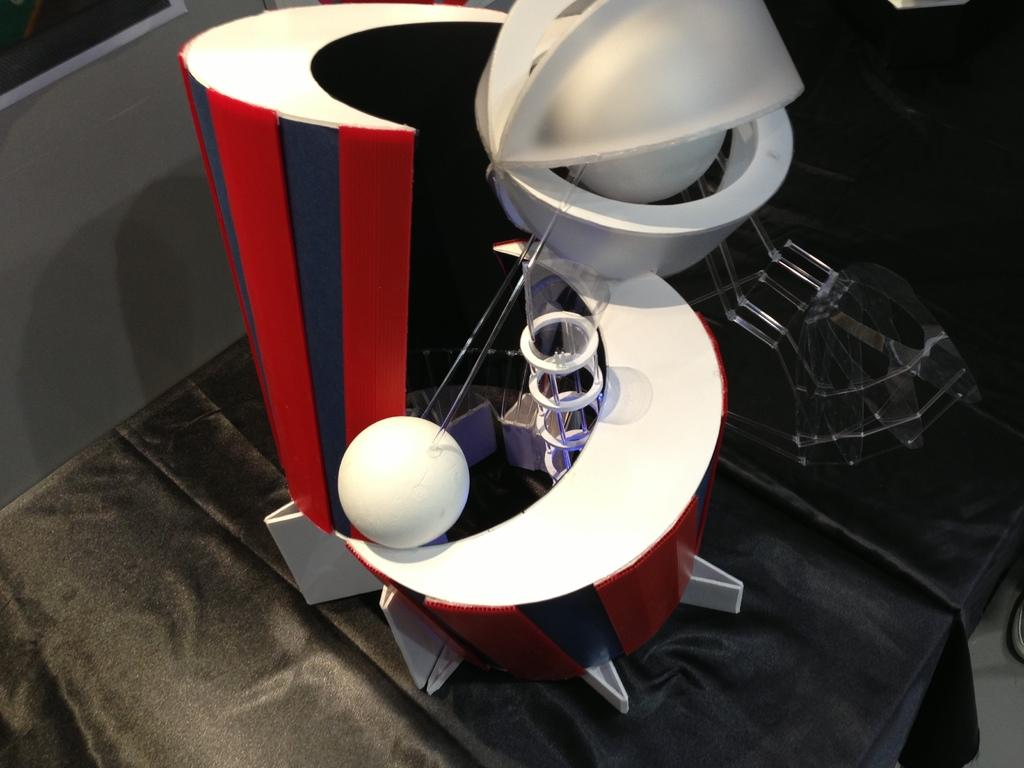What colors are present in the object in the image? The object in the image has red, grey, and white colors. What type of objects can be seen in the image? There are two balls and a cylindrical tube in the image. How does the anger of the brother affect the bat in the image? There is no anger, brother, or bat present in the image. 